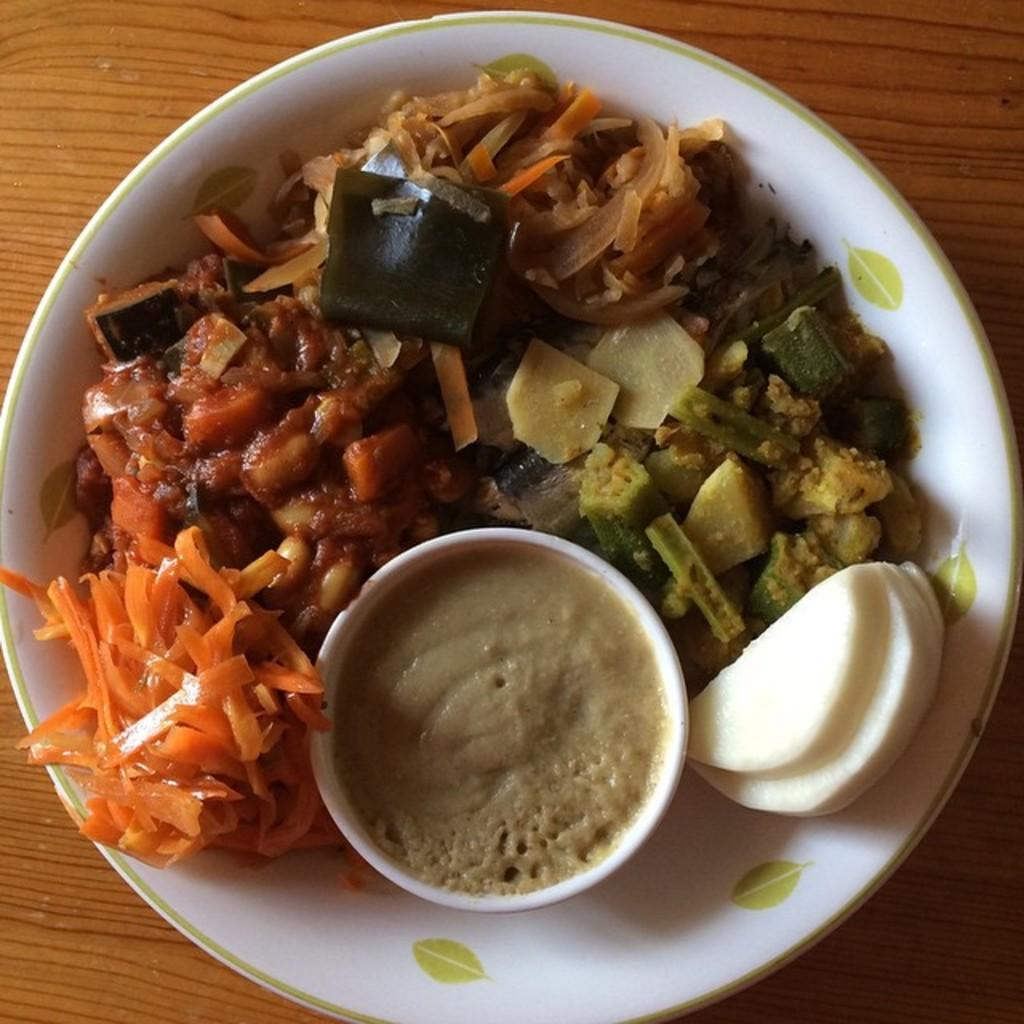What is the color of the bowl in the center of the image? The bowl is white. What is inside the bowl? The bowl contains food items. What can be seen in the background of the image? There is a wooden object in the background, which appears to be a table. What type of curtain is hanging from the ceiling in the image? There is no curtain present in the image. What caused the food items to be placed in the bowl? The text does not provide information about the cause of the food items being placed in the bowl. 